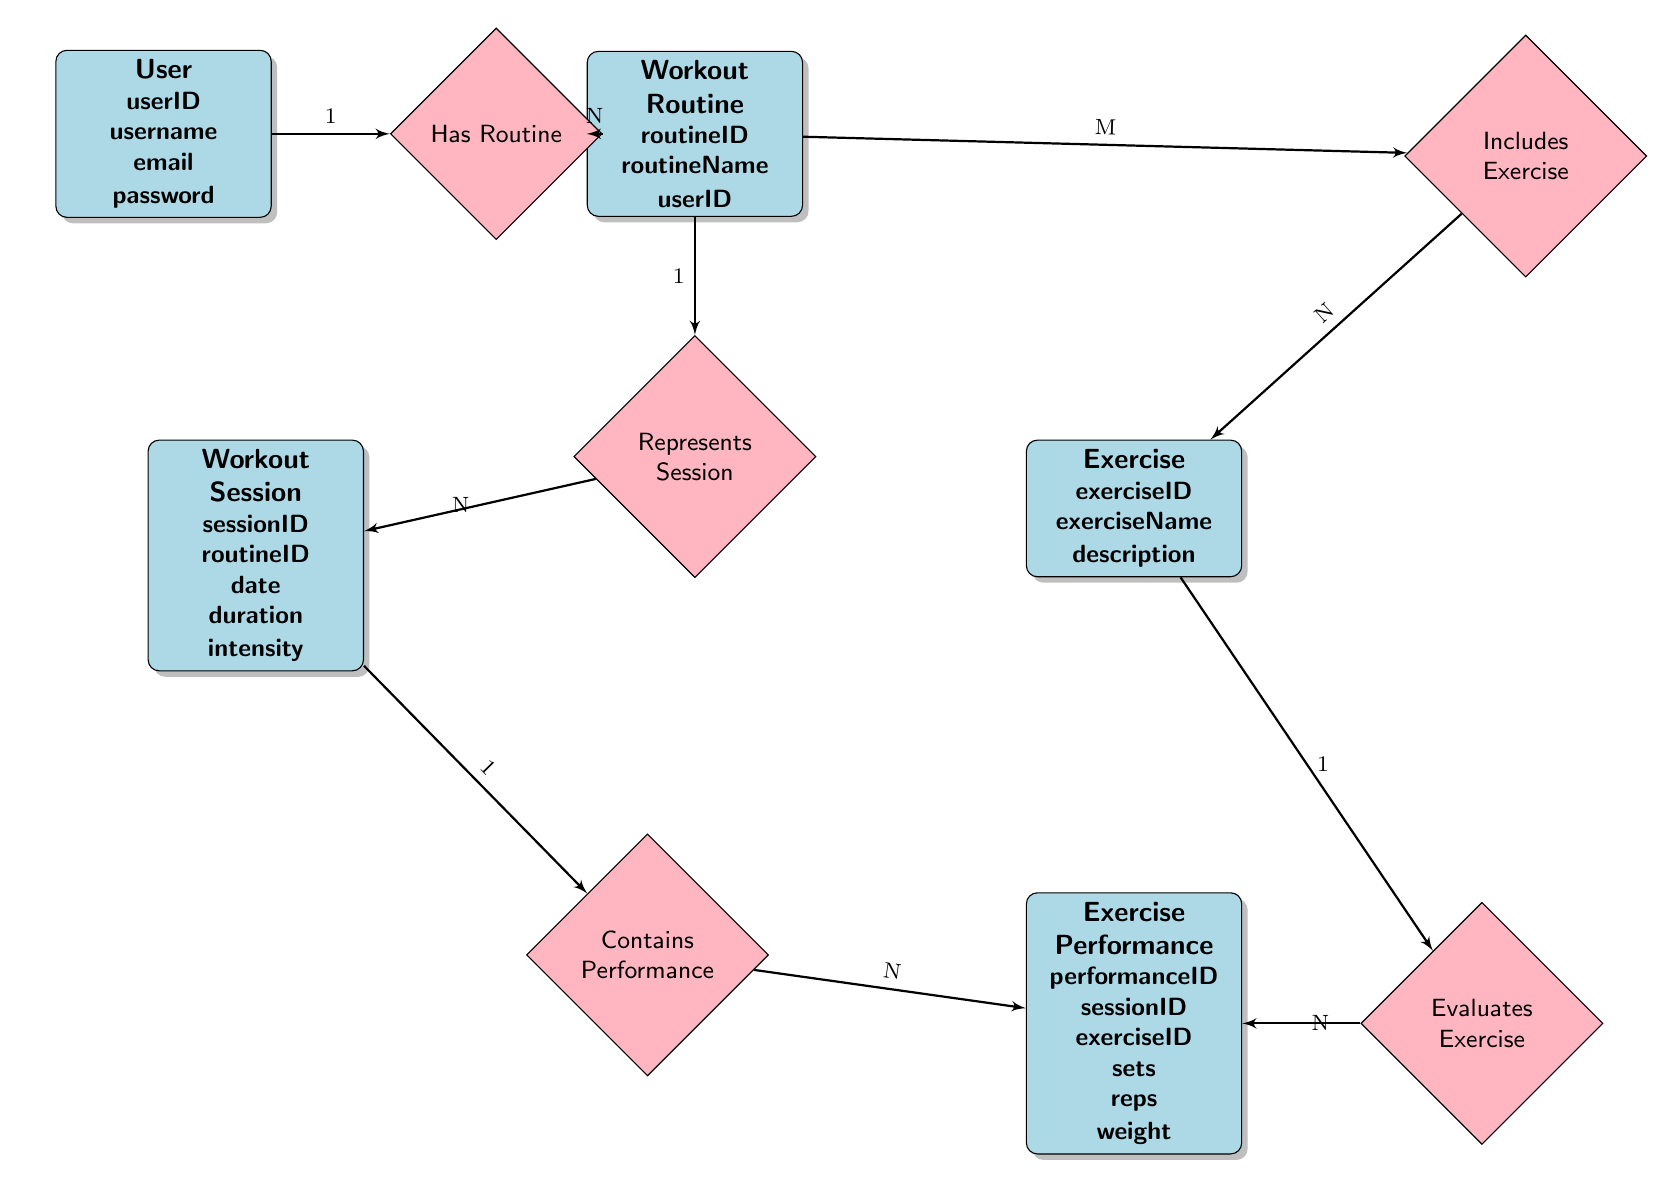What entity holds the user information? The top-left section of the diagram identifies the "User" entity, which comprises attributes such as userID, username, email, and password.
Answer: User How many workout routines can one user have? The relationship "Has Routine" between User and Workout Routine is a one-to-many (1:N) relationship, meaning each User can have multiple Workout Routines, but each Workout Routine is associated with only one User.
Answer: N What type of relationship exists between Workout Routine and Exercise? The relationship "Includes Exercise" connects Workout Routine to Exercise, indicating that it's a many-to-many (M:N) relationship, meaning multiple workout routines can include the same exercises, and exercises can belong to multiple routines.
Answer: M:N How many exercise performances can a workout session have? The relationship "Contains Performance" shows a one-to-many (1:N) connection between Workout Session and Exercise Performance, meaning one Workout Session can contain multiple Exercise Performances, but each Exercise Performance is linked to only one Workout Session.
Answer: N What entity connects exercises to their performance details? The "Exercise Performance" entity serves to connect the details of exercises—including sets, reps, and weight—to the specific workout sessions through a direct assessment of that performance in each session.
Answer: Exercise Performance Which attribute connects Workout Routine to User? The "userID" attribute in the Workout Routine entity demonstrates the link to the User, indicating which user created or is associated with each workout routine.
Answer: userID What is the number of entities in the diagram? By counting the distinct boxes labeled for each entity, we find there are five entities present: User, Workout Routine, Exercise, Workout Session, and Exercise Performance.
Answer: 5 What relationship connects a workout routine to its sessions? The "Represents Session" relationship links Workout Routine and Workout Session, confirming that each workout routine can correspond to multiple workout sessions.
Answer: Represents Session What is the cardinality of the relationship between Exercise and Exercise Performance? The diagram indicates a one-to-many (1:N) relationship through the "Evaluates Exercise" relationship, meaning each exercise can have multiple performance records associated with it.
Answer: 1:N How many attributes does the Workout Session entity have? The Workout Session entity contains five specific attributes: sessionID, routineID, date, duration, and intensity, as indicated in the diagram.
Answer: 5 